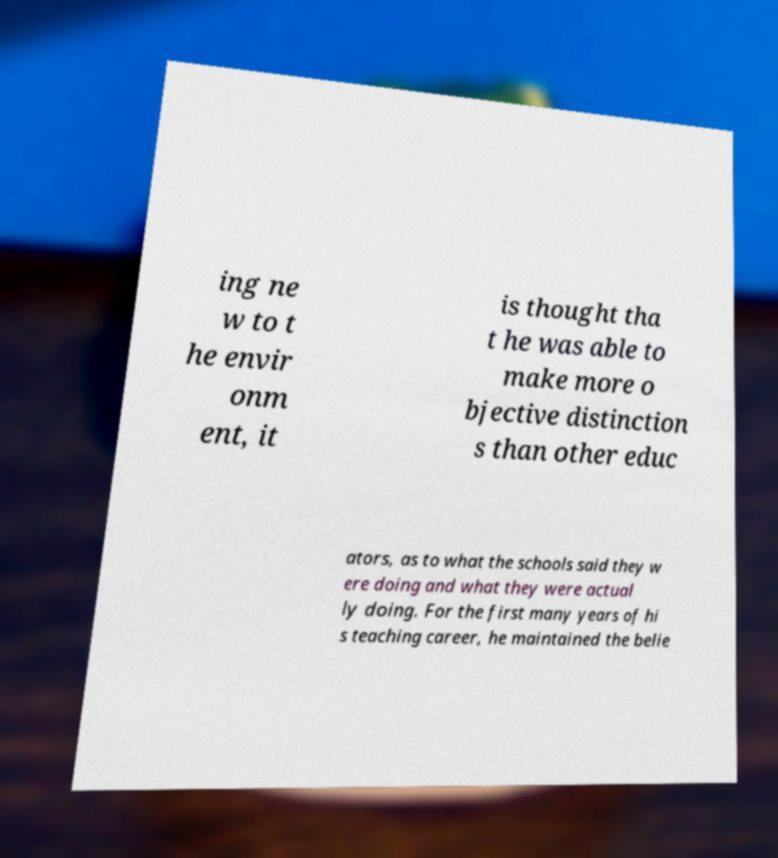Please read and relay the text visible in this image. What does it say? ing ne w to t he envir onm ent, it is thought tha t he was able to make more o bjective distinction s than other educ ators, as to what the schools said they w ere doing and what they were actual ly doing. For the first many years of hi s teaching career, he maintained the belie 